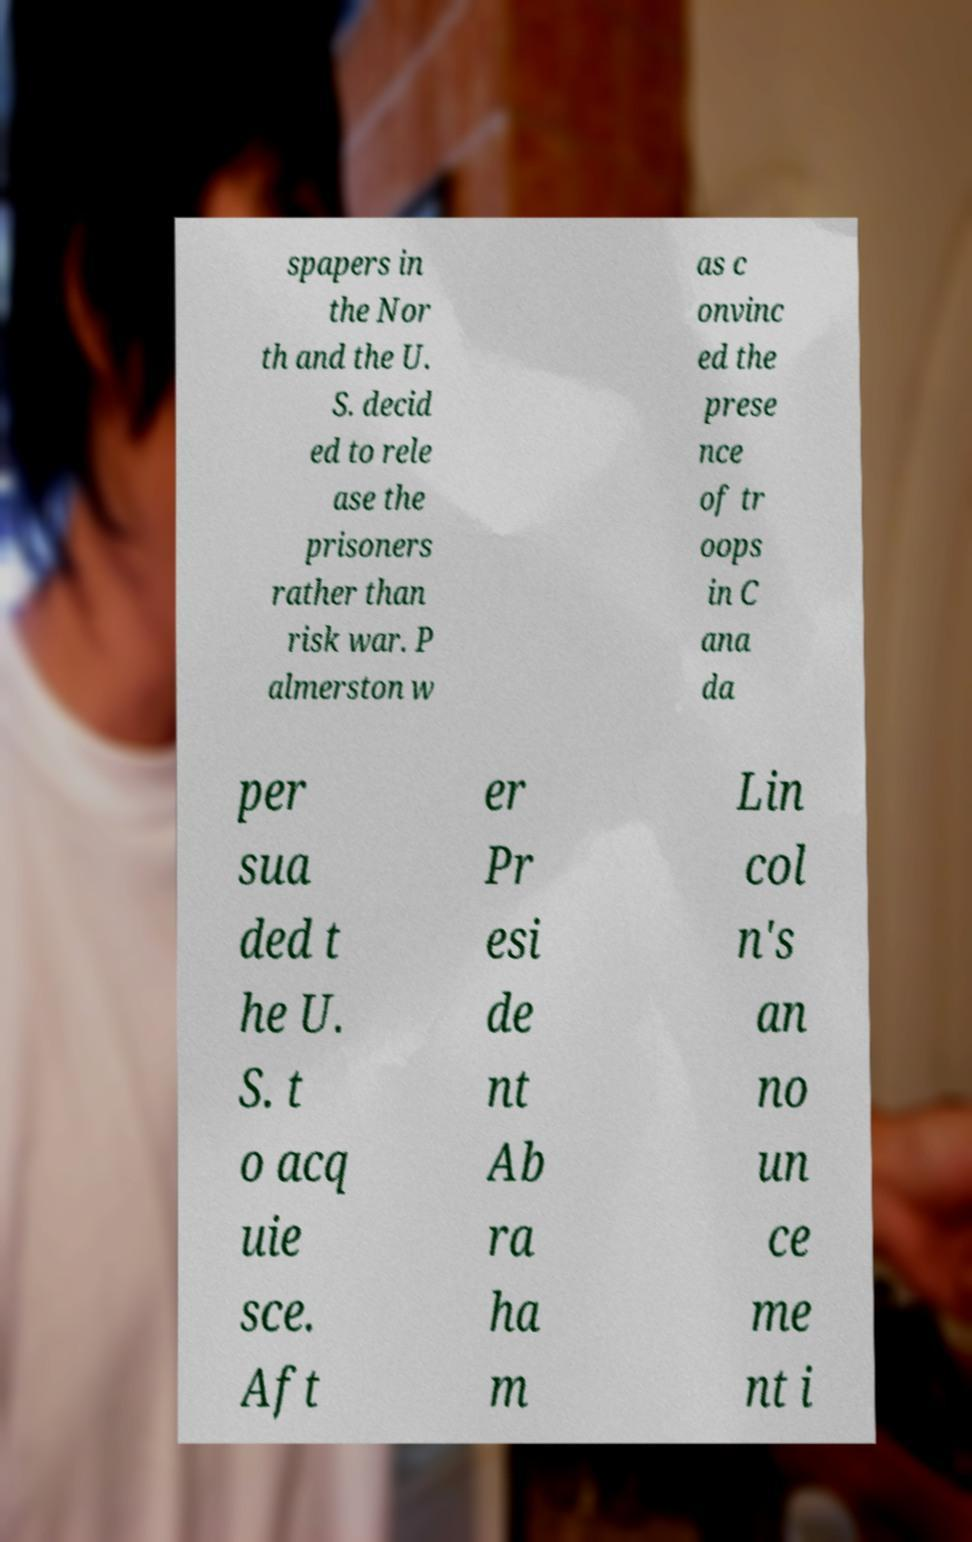There's text embedded in this image that I need extracted. Can you transcribe it verbatim? spapers in the Nor th and the U. S. decid ed to rele ase the prisoners rather than risk war. P almerston w as c onvinc ed the prese nce of tr oops in C ana da per sua ded t he U. S. t o acq uie sce. Aft er Pr esi de nt Ab ra ha m Lin col n's an no un ce me nt i 